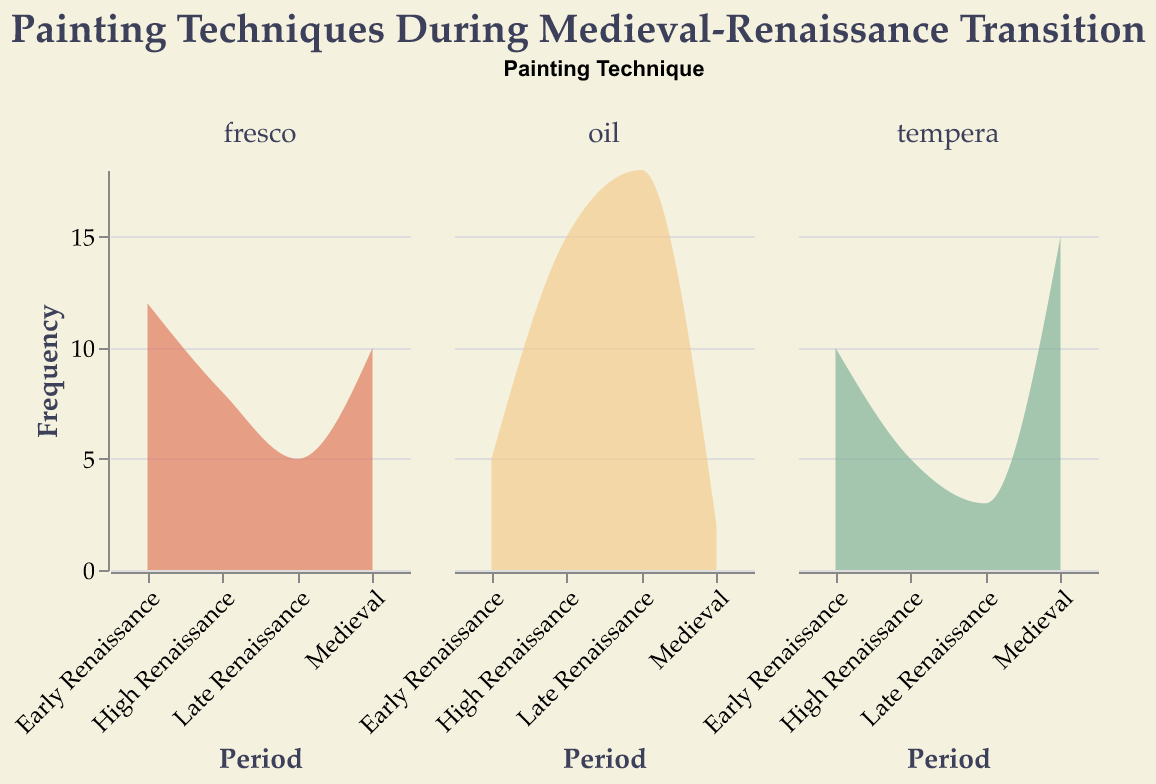What periods are compared in the density plot? The x-axis of the plot displays the different periods which are Medieval, Early Renaissance, High Renaissance, and Late Renaissance, showing the transition phases.
Answer: Medieval, Early Renaissance, High Renaissance, Late Renaissance Which painting technique appears to have the highest frequency during the Late Renaissance? The density plot for the Late Renaissance period shows that the section for oil painting has the highest peak compared to fresco and tempera, indicating the highest frequency.
Answer: Oil How does the frequency of tempera change from the Medieval to the Late Renaissance period? By examining the density plot for the tempera technique across the periods, it is noticeable that the frequency decreases from 15 in the Medieval period to 3 in the Late Renaissance. The frequencies observed are: Medieval (15), Early Renaissance (10), High Renaissance (5), Late Renaissance (3).
Answer: Decreases What is the contrast in the frequency of fresco and oil painting in the High Renaissance period? The density plots show the frequencies for fresco and oil during the High Renaissance. Fresco has a frequency of 8 while oil has a frequency of 15. The difference is calculated as 15 - 8 = 7.
Answer: 7 In which period does fresco painting have the highest frequency? The frequency of fresco painting is highest during the Early Renaissance, as observed from the density plot. The values are: Medieval (10), Early Renaissance (12), High Renaissance (8), Late Renaissance (5).
Answer: Early Renaissance Compare the trend of oil painting from the Medieval to Late Renaissance period. Examining the density plot for oil painting, there is an increasing trend: Medieval (2), Early Renaissance (5), High Renaissance (15), Late Renaissance (18). The frequency of oil painting steadily increases across the periods.
Answer: Increasing What is the sum of the frequencies of tempera painting across all periods? From the density plot, the frequencies for tempera painting across all periods are Medieval (15), Early Renaissance (10), High Renaissance (5), and Late Renaissance (3). Summing these values: 15 + 10 + 5 + 3 = 33.
Answer: 33 Which painting technique shows the most significant change in frequency from the Medieval period to the Late Renaissance period? By comparing the frequencies from the density plots: Fresco (10 -> 5), Tempera (15 -> 3), Oil (2 -> 18). Oil shows the most significant change: 2 to 18, a change of 16.
Answer: Oil Does the frequency of fresco painting increase or decrease during the Renaissance periods? From the density plots: Early Renaissance (12), High Renaissance (8), Late Renaissance (5). The frequency of fresco painting decreases over the Renaissance periods.
Answer: Decrease What is the difference between the highest and lowest frequency for oil painting across all periods? The frequencies of oil painting in the periods are: Medieval (2), Early Renaissance (5), High Renaissance (15), Late Renaissance (18). The highest frequency is 18 and the lowest is 2. The difference is 18 - 2 = 16.
Answer: 16 